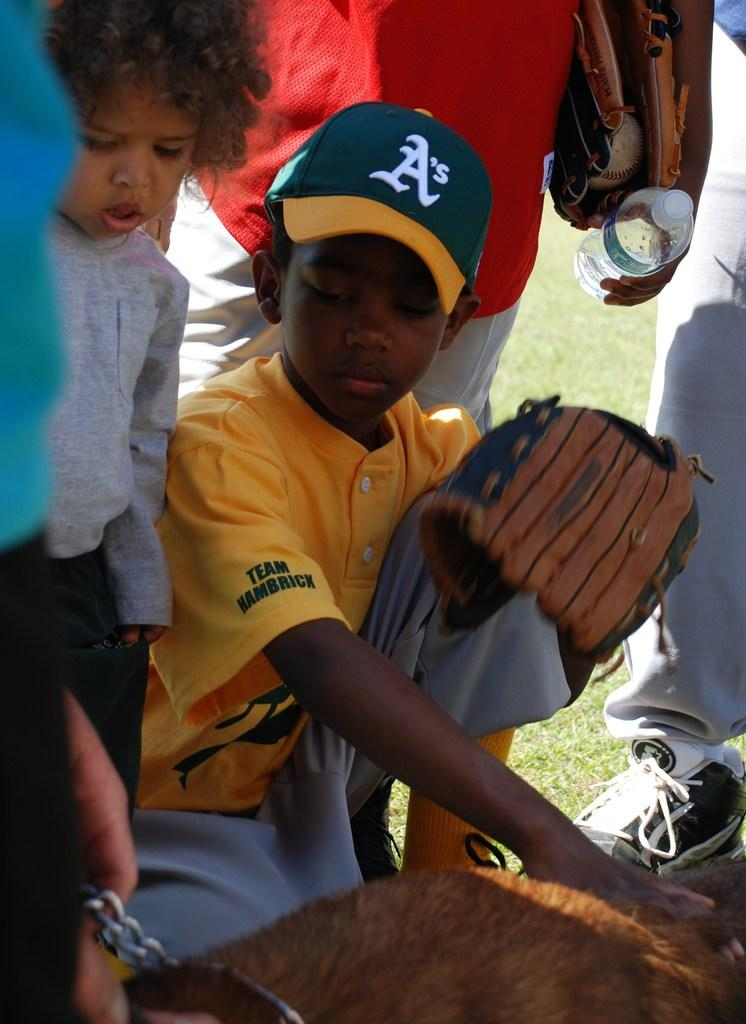Provide a one-sentence caption for the provided image. A boy wears a hat with an A's logo. 